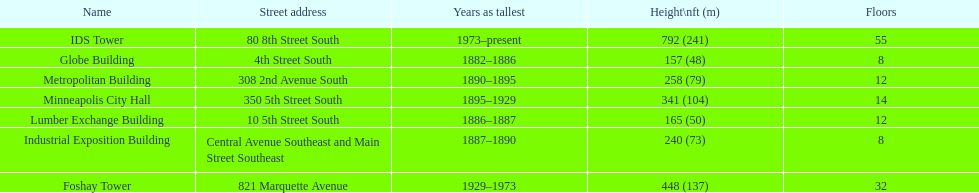Which building has 8 floors and is 240 ft tall? Industrial Exposition Building. 